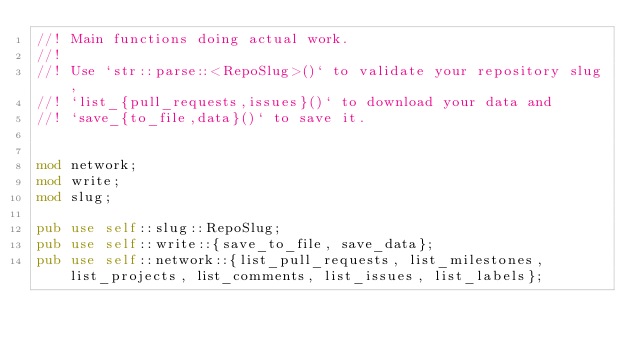<code> <loc_0><loc_0><loc_500><loc_500><_Rust_>//! Main functions doing actual work.
//!
//! Use `str::parse::<RepoSlug>()` to validate your repository slug,
//! `list_{pull_requests,issues}()` to download your data and
//! `save_{to_file,data}()` to save it.


mod network;
mod write;
mod slug;

pub use self::slug::RepoSlug;
pub use self::write::{save_to_file, save_data};
pub use self::network::{list_pull_requests, list_milestones, list_projects, list_comments, list_issues, list_labels};
</code> 